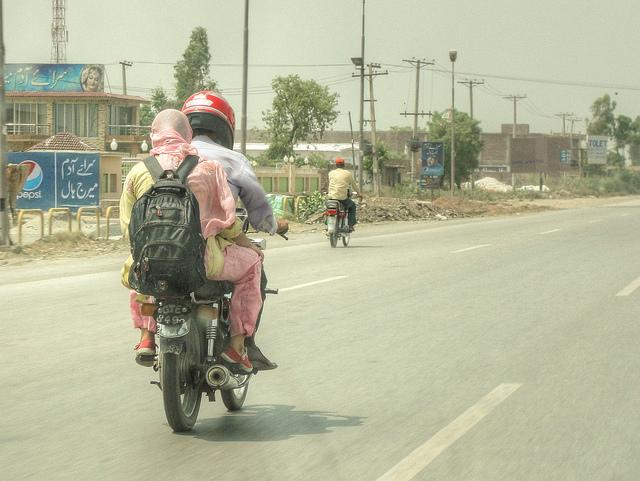Why is the air so hazy? smog 